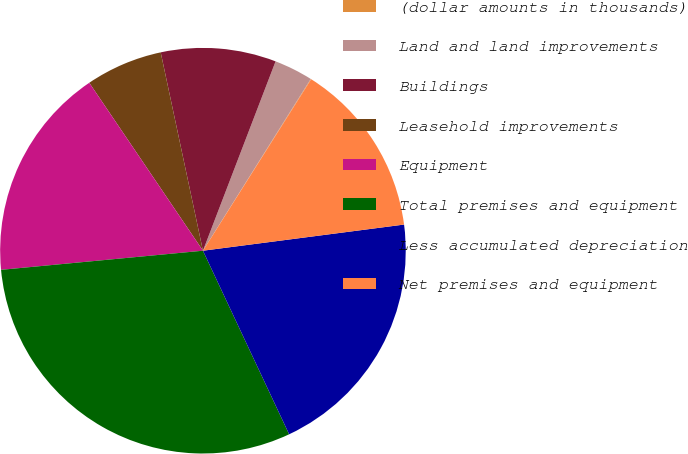Convert chart to OTSL. <chart><loc_0><loc_0><loc_500><loc_500><pie_chart><fcel>(dollar amounts in thousands)<fcel>Land and land improvements<fcel>Buildings<fcel>Leasehold improvements<fcel>Equipment<fcel>Total premises and equipment<fcel>Less accumulated depreciation<fcel>Net premises and equipment<nl><fcel>0.04%<fcel>3.09%<fcel>9.17%<fcel>6.13%<fcel>17.03%<fcel>30.48%<fcel>20.07%<fcel>13.98%<nl></chart> 